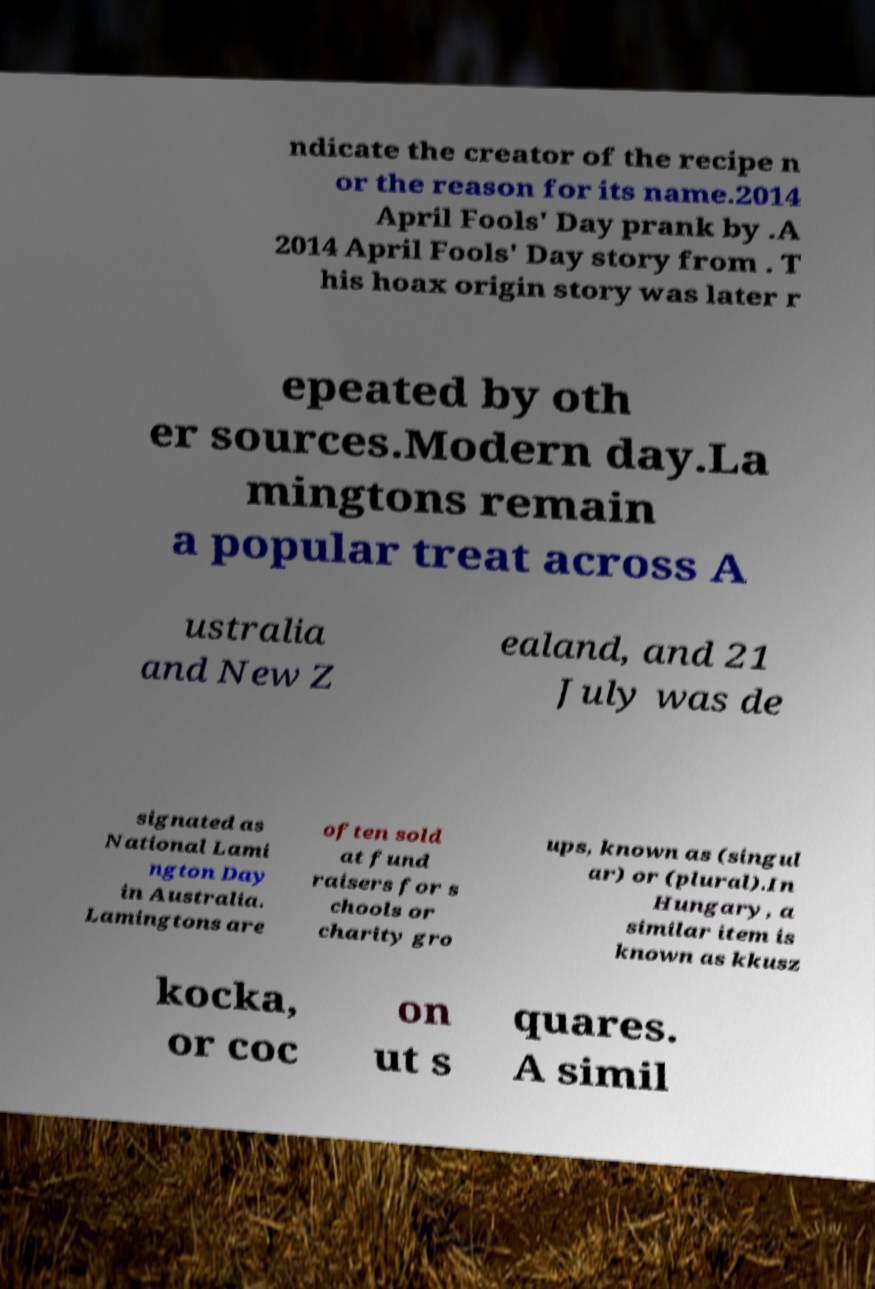Please identify and transcribe the text found in this image. ndicate the creator of the recipe n or the reason for its name.2014 April Fools' Day prank by .A 2014 April Fools' Day story from . T his hoax origin story was later r epeated by oth er sources.Modern day.La mingtons remain a popular treat across A ustralia and New Z ealand, and 21 July was de signated as National Lami ngton Day in Australia. Lamingtons are often sold at fund raisers for s chools or charity gro ups, known as (singul ar) or (plural).In Hungary, a similar item is known as kkusz kocka, or coc on ut s quares. A simil 